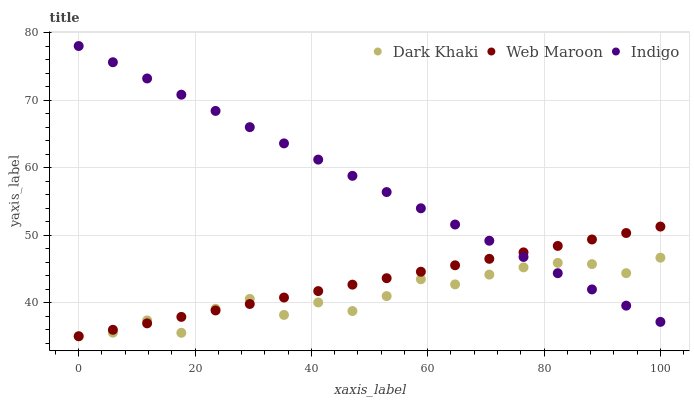Does Dark Khaki have the minimum area under the curve?
Answer yes or no. Yes. Does Indigo have the maximum area under the curve?
Answer yes or no. Yes. Does Web Maroon have the minimum area under the curve?
Answer yes or no. No. Does Web Maroon have the maximum area under the curve?
Answer yes or no. No. Is Indigo the smoothest?
Answer yes or no. Yes. Is Dark Khaki the roughest?
Answer yes or no. Yes. Is Web Maroon the smoothest?
Answer yes or no. No. Is Web Maroon the roughest?
Answer yes or no. No. Does Dark Khaki have the lowest value?
Answer yes or no. Yes. Does Indigo have the lowest value?
Answer yes or no. No. Does Indigo have the highest value?
Answer yes or no. Yes. Does Web Maroon have the highest value?
Answer yes or no. No. Does Dark Khaki intersect Web Maroon?
Answer yes or no. Yes. Is Dark Khaki less than Web Maroon?
Answer yes or no. No. Is Dark Khaki greater than Web Maroon?
Answer yes or no. No. 